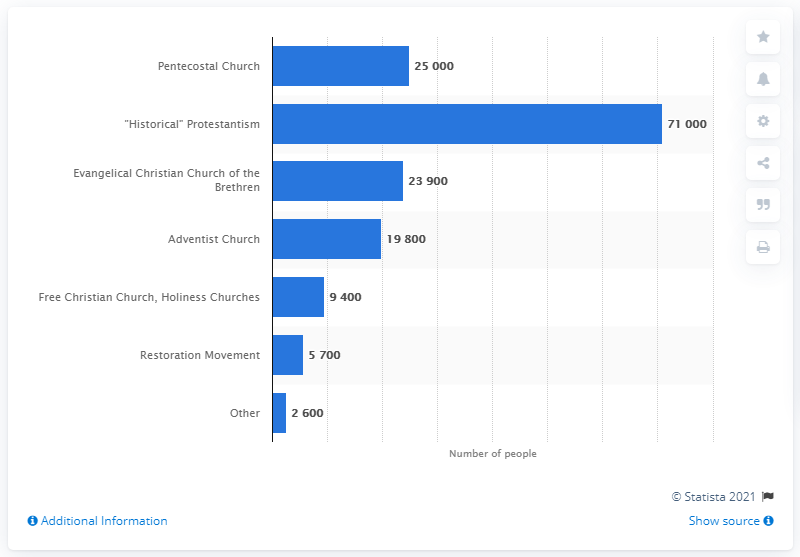Draw attention to some important aspects in this diagram. In 2020, there were approximately 71,000 historical Protestants in Italy. 